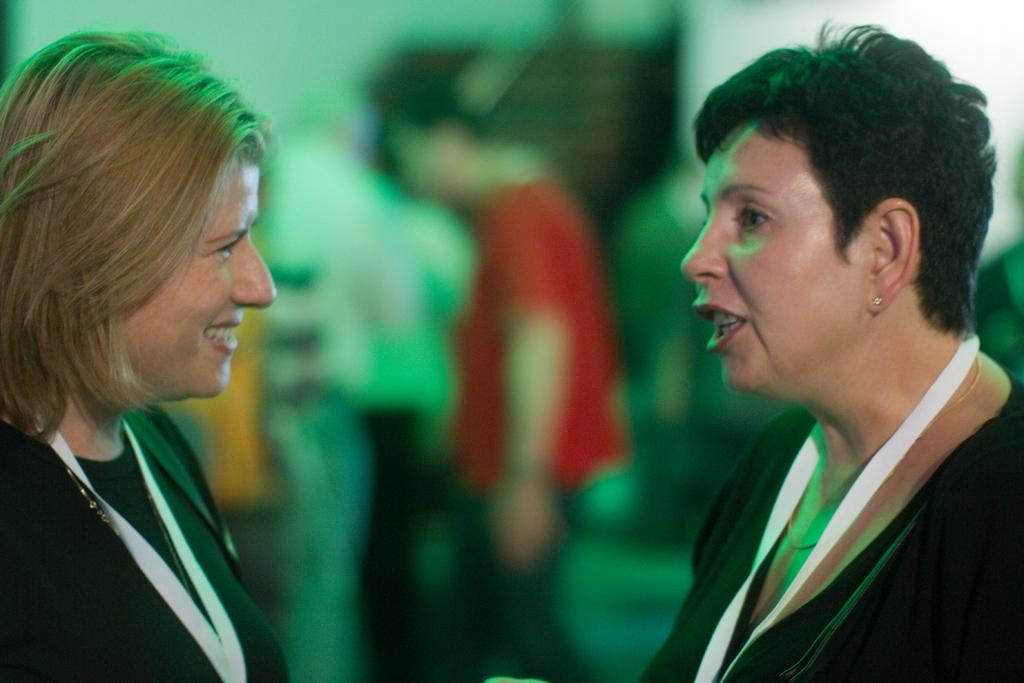How many women are in the image? There are two women in the image. What are the women wearing? The women are wearing black dresses. What are the women doing in the image? The women are standing. Can you describe the background of the image? The background of the image is blurry. What else can be seen in the background? There are people standing and other objects visible in the background. What type of alarm can be heard going off in the image? There is no alarm present in the image, and therefore no such sound can be heard. 